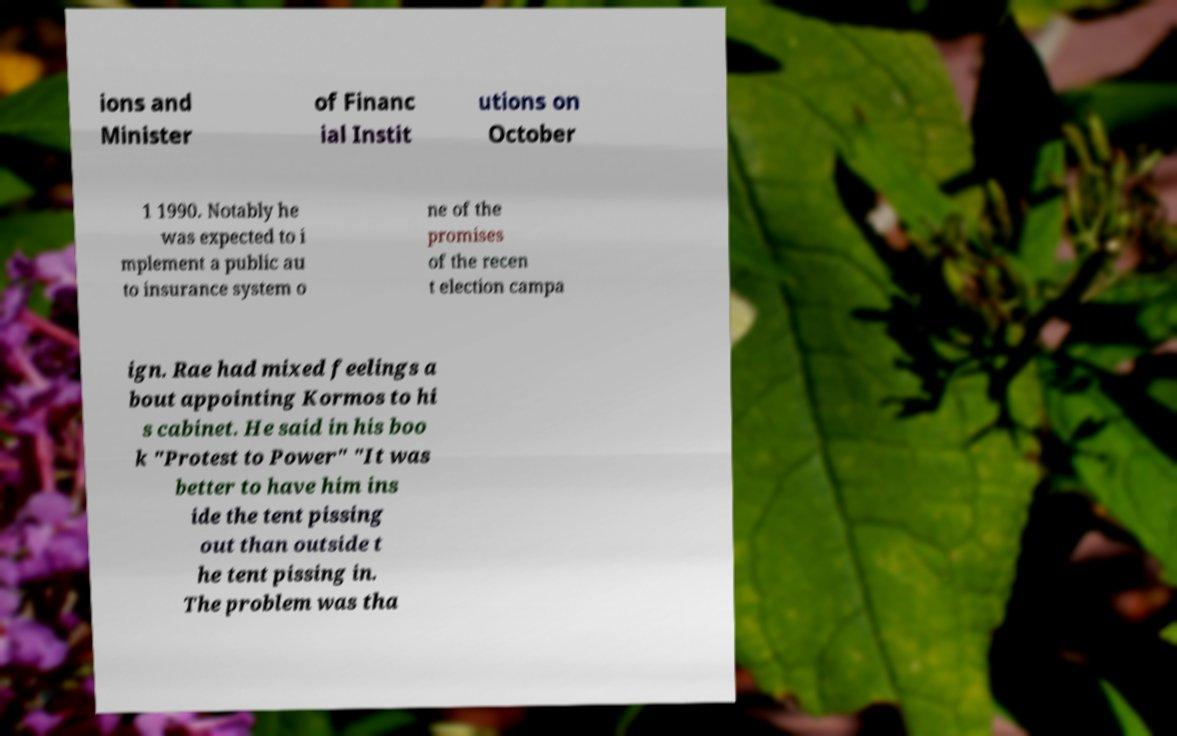Please identify and transcribe the text found in this image. ions and Minister of Financ ial Instit utions on October 1 1990. Notably he was expected to i mplement a public au to insurance system o ne of the promises of the recen t election campa ign. Rae had mixed feelings a bout appointing Kormos to hi s cabinet. He said in his boo k "Protest to Power" "It was better to have him ins ide the tent pissing out than outside t he tent pissing in. The problem was tha 